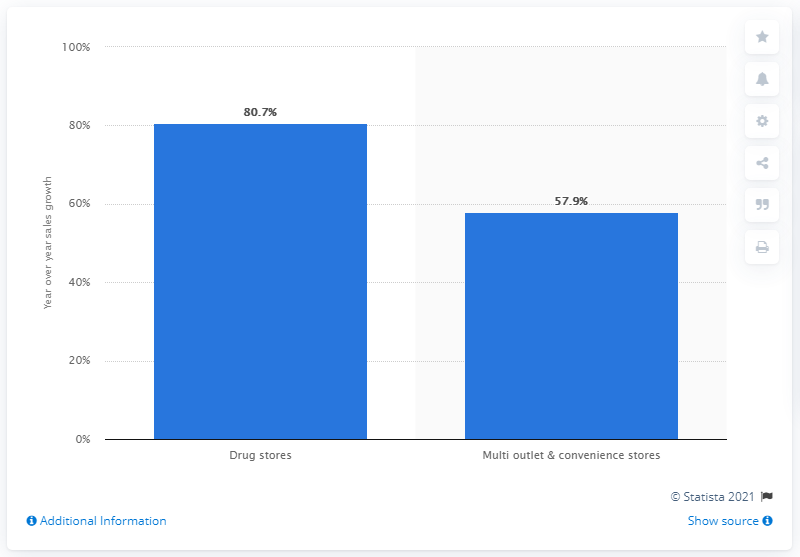Give some essential details in this illustration. The sales of hand sanitizers in drug stores increased by 80.7% in the week ended February 23, 2020, compared to the previous week. The sales of hand sanitizers in multi-outlet and convenience stores grew by 57.9% in the week ended February 23, 2020. 